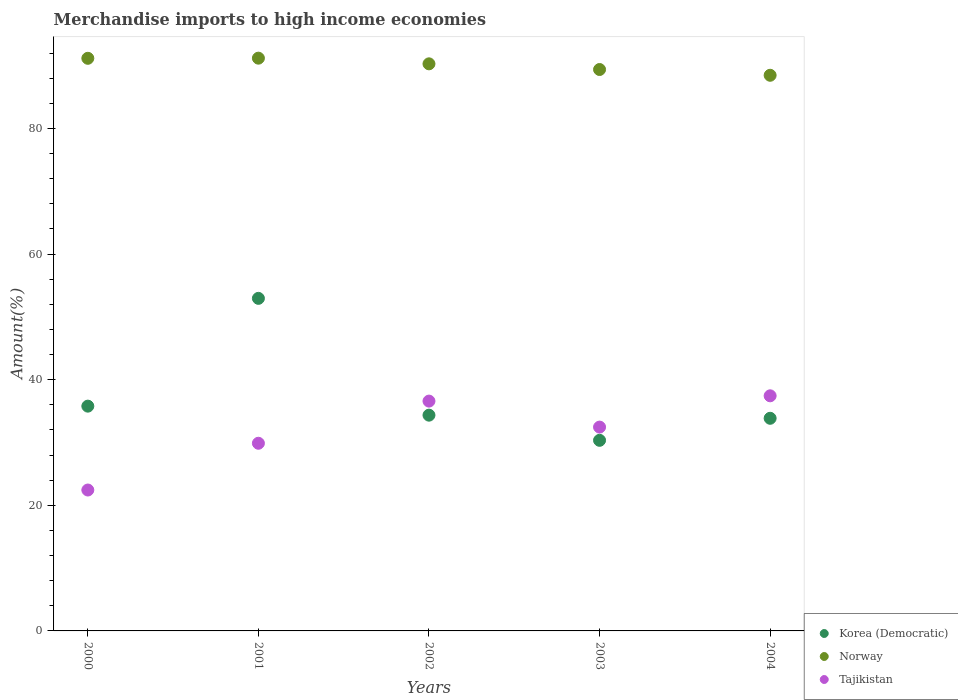How many different coloured dotlines are there?
Your answer should be very brief. 3. What is the percentage of amount earned from merchandise imports in Tajikistan in 2000?
Keep it short and to the point. 22.43. Across all years, what is the maximum percentage of amount earned from merchandise imports in Norway?
Offer a very short reply. 91.18. Across all years, what is the minimum percentage of amount earned from merchandise imports in Norway?
Make the answer very short. 88.46. In which year was the percentage of amount earned from merchandise imports in Norway maximum?
Provide a succinct answer. 2001. In which year was the percentage of amount earned from merchandise imports in Korea (Democratic) minimum?
Offer a very short reply. 2003. What is the total percentage of amount earned from merchandise imports in Tajikistan in the graph?
Keep it short and to the point. 158.77. What is the difference between the percentage of amount earned from merchandise imports in Korea (Democratic) in 2000 and that in 2004?
Your answer should be very brief. 1.93. What is the difference between the percentage of amount earned from merchandise imports in Tajikistan in 2003 and the percentage of amount earned from merchandise imports in Korea (Democratic) in 2001?
Offer a terse response. -20.49. What is the average percentage of amount earned from merchandise imports in Norway per year?
Keep it short and to the point. 90.09. In the year 2001, what is the difference between the percentage of amount earned from merchandise imports in Korea (Democratic) and percentage of amount earned from merchandise imports in Norway?
Provide a short and direct response. -38.24. In how many years, is the percentage of amount earned from merchandise imports in Tajikistan greater than 72 %?
Offer a very short reply. 0. What is the ratio of the percentage of amount earned from merchandise imports in Korea (Democratic) in 2000 to that in 2001?
Provide a succinct answer. 0.68. Is the percentage of amount earned from merchandise imports in Norway in 2002 less than that in 2004?
Give a very brief answer. No. What is the difference between the highest and the second highest percentage of amount earned from merchandise imports in Norway?
Your response must be concise. 0.02. What is the difference between the highest and the lowest percentage of amount earned from merchandise imports in Norway?
Your response must be concise. 2.72. In how many years, is the percentage of amount earned from merchandise imports in Tajikistan greater than the average percentage of amount earned from merchandise imports in Tajikistan taken over all years?
Your answer should be compact. 3. Does the percentage of amount earned from merchandise imports in Norway monotonically increase over the years?
Provide a succinct answer. No. Is the percentage of amount earned from merchandise imports in Norway strictly greater than the percentage of amount earned from merchandise imports in Korea (Democratic) over the years?
Your answer should be compact. Yes. Does the graph contain any zero values?
Keep it short and to the point. No. Where does the legend appear in the graph?
Your response must be concise. Bottom right. How are the legend labels stacked?
Make the answer very short. Vertical. What is the title of the graph?
Provide a short and direct response. Merchandise imports to high income economies. What is the label or title of the Y-axis?
Offer a very short reply. Amount(%). What is the Amount(%) in Korea (Democratic) in 2000?
Give a very brief answer. 35.78. What is the Amount(%) in Norway in 2000?
Offer a terse response. 91.16. What is the Amount(%) in Tajikistan in 2000?
Keep it short and to the point. 22.43. What is the Amount(%) in Korea (Democratic) in 2001?
Offer a very short reply. 52.94. What is the Amount(%) in Norway in 2001?
Offer a terse response. 91.18. What is the Amount(%) in Tajikistan in 2001?
Give a very brief answer. 29.88. What is the Amount(%) in Korea (Democratic) in 2002?
Offer a very short reply. 34.35. What is the Amount(%) in Norway in 2002?
Offer a very short reply. 90.28. What is the Amount(%) in Tajikistan in 2002?
Your response must be concise. 36.59. What is the Amount(%) in Korea (Democratic) in 2003?
Give a very brief answer. 30.34. What is the Amount(%) in Norway in 2003?
Ensure brevity in your answer.  89.37. What is the Amount(%) of Tajikistan in 2003?
Give a very brief answer. 32.45. What is the Amount(%) in Korea (Democratic) in 2004?
Give a very brief answer. 33.85. What is the Amount(%) of Norway in 2004?
Your answer should be compact. 88.46. What is the Amount(%) of Tajikistan in 2004?
Your answer should be very brief. 37.43. Across all years, what is the maximum Amount(%) in Korea (Democratic)?
Provide a short and direct response. 52.94. Across all years, what is the maximum Amount(%) of Norway?
Give a very brief answer. 91.18. Across all years, what is the maximum Amount(%) of Tajikistan?
Give a very brief answer. 37.43. Across all years, what is the minimum Amount(%) in Korea (Democratic)?
Give a very brief answer. 30.34. Across all years, what is the minimum Amount(%) in Norway?
Make the answer very short. 88.46. Across all years, what is the minimum Amount(%) in Tajikistan?
Your answer should be compact. 22.43. What is the total Amount(%) in Korea (Democratic) in the graph?
Ensure brevity in your answer.  187.27. What is the total Amount(%) in Norway in the graph?
Your response must be concise. 450.45. What is the total Amount(%) in Tajikistan in the graph?
Provide a succinct answer. 158.77. What is the difference between the Amount(%) in Korea (Democratic) in 2000 and that in 2001?
Give a very brief answer. -17.16. What is the difference between the Amount(%) of Norway in 2000 and that in 2001?
Provide a short and direct response. -0.02. What is the difference between the Amount(%) in Tajikistan in 2000 and that in 2001?
Offer a very short reply. -7.44. What is the difference between the Amount(%) in Korea (Democratic) in 2000 and that in 2002?
Give a very brief answer. 1.44. What is the difference between the Amount(%) in Norway in 2000 and that in 2002?
Ensure brevity in your answer.  0.88. What is the difference between the Amount(%) in Tajikistan in 2000 and that in 2002?
Your answer should be compact. -14.15. What is the difference between the Amount(%) in Korea (Democratic) in 2000 and that in 2003?
Ensure brevity in your answer.  5.44. What is the difference between the Amount(%) in Norway in 2000 and that in 2003?
Give a very brief answer. 1.78. What is the difference between the Amount(%) in Tajikistan in 2000 and that in 2003?
Ensure brevity in your answer.  -10.02. What is the difference between the Amount(%) in Korea (Democratic) in 2000 and that in 2004?
Offer a very short reply. 1.93. What is the difference between the Amount(%) in Norway in 2000 and that in 2004?
Offer a terse response. 2.7. What is the difference between the Amount(%) in Tajikistan in 2000 and that in 2004?
Offer a terse response. -15. What is the difference between the Amount(%) of Korea (Democratic) in 2001 and that in 2002?
Make the answer very short. 18.59. What is the difference between the Amount(%) of Norway in 2001 and that in 2002?
Make the answer very short. 0.9. What is the difference between the Amount(%) in Tajikistan in 2001 and that in 2002?
Provide a succinct answer. -6.71. What is the difference between the Amount(%) in Korea (Democratic) in 2001 and that in 2003?
Your response must be concise. 22.6. What is the difference between the Amount(%) in Norway in 2001 and that in 2003?
Your answer should be very brief. 1.81. What is the difference between the Amount(%) in Tajikistan in 2001 and that in 2003?
Provide a short and direct response. -2.57. What is the difference between the Amount(%) of Korea (Democratic) in 2001 and that in 2004?
Provide a succinct answer. 19.09. What is the difference between the Amount(%) of Norway in 2001 and that in 2004?
Provide a short and direct response. 2.72. What is the difference between the Amount(%) in Tajikistan in 2001 and that in 2004?
Your answer should be very brief. -7.55. What is the difference between the Amount(%) in Korea (Democratic) in 2002 and that in 2003?
Give a very brief answer. 4.01. What is the difference between the Amount(%) of Norway in 2002 and that in 2003?
Offer a terse response. 0.9. What is the difference between the Amount(%) in Tajikistan in 2002 and that in 2003?
Your answer should be compact. 4.14. What is the difference between the Amount(%) in Korea (Democratic) in 2002 and that in 2004?
Give a very brief answer. 0.5. What is the difference between the Amount(%) in Norway in 2002 and that in 2004?
Offer a very short reply. 1.82. What is the difference between the Amount(%) in Tajikistan in 2002 and that in 2004?
Provide a succinct answer. -0.84. What is the difference between the Amount(%) in Korea (Democratic) in 2003 and that in 2004?
Keep it short and to the point. -3.51. What is the difference between the Amount(%) in Norway in 2003 and that in 2004?
Your answer should be very brief. 0.92. What is the difference between the Amount(%) in Tajikistan in 2003 and that in 2004?
Ensure brevity in your answer.  -4.98. What is the difference between the Amount(%) of Korea (Democratic) in 2000 and the Amount(%) of Norway in 2001?
Provide a succinct answer. -55.4. What is the difference between the Amount(%) in Korea (Democratic) in 2000 and the Amount(%) in Tajikistan in 2001?
Provide a succinct answer. 5.91. What is the difference between the Amount(%) in Norway in 2000 and the Amount(%) in Tajikistan in 2001?
Your response must be concise. 61.28. What is the difference between the Amount(%) in Korea (Democratic) in 2000 and the Amount(%) in Norway in 2002?
Provide a short and direct response. -54.49. What is the difference between the Amount(%) in Korea (Democratic) in 2000 and the Amount(%) in Tajikistan in 2002?
Make the answer very short. -0.8. What is the difference between the Amount(%) in Norway in 2000 and the Amount(%) in Tajikistan in 2002?
Your answer should be compact. 54.57. What is the difference between the Amount(%) in Korea (Democratic) in 2000 and the Amount(%) in Norway in 2003?
Ensure brevity in your answer.  -53.59. What is the difference between the Amount(%) in Korea (Democratic) in 2000 and the Amount(%) in Tajikistan in 2003?
Provide a short and direct response. 3.34. What is the difference between the Amount(%) of Norway in 2000 and the Amount(%) of Tajikistan in 2003?
Offer a terse response. 58.71. What is the difference between the Amount(%) of Korea (Democratic) in 2000 and the Amount(%) of Norway in 2004?
Offer a terse response. -52.67. What is the difference between the Amount(%) in Korea (Democratic) in 2000 and the Amount(%) in Tajikistan in 2004?
Make the answer very short. -1.64. What is the difference between the Amount(%) of Norway in 2000 and the Amount(%) of Tajikistan in 2004?
Offer a very short reply. 53.73. What is the difference between the Amount(%) in Korea (Democratic) in 2001 and the Amount(%) in Norway in 2002?
Keep it short and to the point. -37.34. What is the difference between the Amount(%) of Korea (Democratic) in 2001 and the Amount(%) of Tajikistan in 2002?
Provide a short and direct response. 16.36. What is the difference between the Amount(%) in Norway in 2001 and the Amount(%) in Tajikistan in 2002?
Provide a succinct answer. 54.59. What is the difference between the Amount(%) of Korea (Democratic) in 2001 and the Amount(%) of Norway in 2003?
Give a very brief answer. -36.43. What is the difference between the Amount(%) of Korea (Democratic) in 2001 and the Amount(%) of Tajikistan in 2003?
Your answer should be very brief. 20.49. What is the difference between the Amount(%) of Norway in 2001 and the Amount(%) of Tajikistan in 2003?
Offer a very short reply. 58.73. What is the difference between the Amount(%) of Korea (Democratic) in 2001 and the Amount(%) of Norway in 2004?
Make the answer very short. -35.51. What is the difference between the Amount(%) in Korea (Democratic) in 2001 and the Amount(%) in Tajikistan in 2004?
Provide a succinct answer. 15.51. What is the difference between the Amount(%) of Norway in 2001 and the Amount(%) of Tajikistan in 2004?
Make the answer very short. 53.75. What is the difference between the Amount(%) in Korea (Democratic) in 2002 and the Amount(%) in Norway in 2003?
Give a very brief answer. -55.03. What is the difference between the Amount(%) in Korea (Democratic) in 2002 and the Amount(%) in Tajikistan in 2003?
Provide a short and direct response. 1.9. What is the difference between the Amount(%) of Norway in 2002 and the Amount(%) of Tajikistan in 2003?
Provide a succinct answer. 57.83. What is the difference between the Amount(%) in Korea (Democratic) in 2002 and the Amount(%) in Norway in 2004?
Your response must be concise. -54.11. What is the difference between the Amount(%) in Korea (Democratic) in 2002 and the Amount(%) in Tajikistan in 2004?
Your response must be concise. -3.08. What is the difference between the Amount(%) of Norway in 2002 and the Amount(%) of Tajikistan in 2004?
Your response must be concise. 52.85. What is the difference between the Amount(%) of Korea (Democratic) in 2003 and the Amount(%) of Norway in 2004?
Your answer should be very brief. -58.11. What is the difference between the Amount(%) of Korea (Democratic) in 2003 and the Amount(%) of Tajikistan in 2004?
Provide a succinct answer. -7.09. What is the difference between the Amount(%) in Norway in 2003 and the Amount(%) in Tajikistan in 2004?
Give a very brief answer. 51.95. What is the average Amount(%) in Korea (Democratic) per year?
Provide a short and direct response. 37.45. What is the average Amount(%) in Norway per year?
Provide a succinct answer. 90.09. What is the average Amount(%) in Tajikistan per year?
Your answer should be compact. 31.75. In the year 2000, what is the difference between the Amount(%) of Korea (Democratic) and Amount(%) of Norway?
Offer a terse response. -55.37. In the year 2000, what is the difference between the Amount(%) of Korea (Democratic) and Amount(%) of Tajikistan?
Ensure brevity in your answer.  13.35. In the year 2000, what is the difference between the Amount(%) in Norway and Amount(%) in Tajikistan?
Provide a short and direct response. 68.73. In the year 2001, what is the difference between the Amount(%) in Korea (Democratic) and Amount(%) in Norway?
Your response must be concise. -38.24. In the year 2001, what is the difference between the Amount(%) of Korea (Democratic) and Amount(%) of Tajikistan?
Keep it short and to the point. 23.07. In the year 2001, what is the difference between the Amount(%) in Norway and Amount(%) in Tajikistan?
Your answer should be compact. 61.3. In the year 2002, what is the difference between the Amount(%) in Korea (Democratic) and Amount(%) in Norway?
Ensure brevity in your answer.  -55.93. In the year 2002, what is the difference between the Amount(%) of Korea (Democratic) and Amount(%) of Tajikistan?
Your answer should be very brief. -2.24. In the year 2002, what is the difference between the Amount(%) in Norway and Amount(%) in Tajikistan?
Your answer should be compact. 53.69. In the year 2003, what is the difference between the Amount(%) in Korea (Democratic) and Amount(%) in Norway?
Give a very brief answer. -59.03. In the year 2003, what is the difference between the Amount(%) of Korea (Democratic) and Amount(%) of Tajikistan?
Provide a short and direct response. -2.11. In the year 2003, what is the difference between the Amount(%) in Norway and Amount(%) in Tajikistan?
Provide a short and direct response. 56.93. In the year 2004, what is the difference between the Amount(%) in Korea (Democratic) and Amount(%) in Norway?
Provide a succinct answer. -54.61. In the year 2004, what is the difference between the Amount(%) of Korea (Democratic) and Amount(%) of Tajikistan?
Your answer should be very brief. -3.58. In the year 2004, what is the difference between the Amount(%) of Norway and Amount(%) of Tajikistan?
Keep it short and to the point. 51.03. What is the ratio of the Amount(%) of Korea (Democratic) in 2000 to that in 2001?
Ensure brevity in your answer.  0.68. What is the ratio of the Amount(%) of Norway in 2000 to that in 2001?
Offer a very short reply. 1. What is the ratio of the Amount(%) of Tajikistan in 2000 to that in 2001?
Provide a succinct answer. 0.75. What is the ratio of the Amount(%) of Korea (Democratic) in 2000 to that in 2002?
Your answer should be compact. 1.04. What is the ratio of the Amount(%) of Norway in 2000 to that in 2002?
Provide a succinct answer. 1.01. What is the ratio of the Amount(%) in Tajikistan in 2000 to that in 2002?
Offer a very short reply. 0.61. What is the ratio of the Amount(%) in Korea (Democratic) in 2000 to that in 2003?
Ensure brevity in your answer.  1.18. What is the ratio of the Amount(%) in Tajikistan in 2000 to that in 2003?
Your answer should be compact. 0.69. What is the ratio of the Amount(%) in Korea (Democratic) in 2000 to that in 2004?
Your answer should be very brief. 1.06. What is the ratio of the Amount(%) of Norway in 2000 to that in 2004?
Make the answer very short. 1.03. What is the ratio of the Amount(%) in Tajikistan in 2000 to that in 2004?
Ensure brevity in your answer.  0.6. What is the ratio of the Amount(%) in Korea (Democratic) in 2001 to that in 2002?
Your answer should be compact. 1.54. What is the ratio of the Amount(%) of Tajikistan in 2001 to that in 2002?
Give a very brief answer. 0.82. What is the ratio of the Amount(%) of Korea (Democratic) in 2001 to that in 2003?
Your answer should be compact. 1.74. What is the ratio of the Amount(%) of Norway in 2001 to that in 2003?
Keep it short and to the point. 1.02. What is the ratio of the Amount(%) in Tajikistan in 2001 to that in 2003?
Give a very brief answer. 0.92. What is the ratio of the Amount(%) of Korea (Democratic) in 2001 to that in 2004?
Your answer should be compact. 1.56. What is the ratio of the Amount(%) of Norway in 2001 to that in 2004?
Give a very brief answer. 1.03. What is the ratio of the Amount(%) of Tajikistan in 2001 to that in 2004?
Provide a short and direct response. 0.8. What is the ratio of the Amount(%) of Korea (Democratic) in 2002 to that in 2003?
Keep it short and to the point. 1.13. What is the ratio of the Amount(%) of Norway in 2002 to that in 2003?
Your response must be concise. 1.01. What is the ratio of the Amount(%) in Tajikistan in 2002 to that in 2003?
Give a very brief answer. 1.13. What is the ratio of the Amount(%) in Korea (Democratic) in 2002 to that in 2004?
Your answer should be very brief. 1.01. What is the ratio of the Amount(%) of Norway in 2002 to that in 2004?
Provide a succinct answer. 1.02. What is the ratio of the Amount(%) of Tajikistan in 2002 to that in 2004?
Offer a very short reply. 0.98. What is the ratio of the Amount(%) of Korea (Democratic) in 2003 to that in 2004?
Your answer should be compact. 0.9. What is the ratio of the Amount(%) in Norway in 2003 to that in 2004?
Your answer should be very brief. 1.01. What is the ratio of the Amount(%) of Tajikistan in 2003 to that in 2004?
Make the answer very short. 0.87. What is the difference between the highest and the second highest Amount(%) in Korea (Democratic)?
Your answer should be very brief. 17.16. What is the difference between the highest and the second highest Amount(%) in Norway?
Make the answer very short. 0.02. What is the difference between the highest and the second highest Amount(%) in Tajikistan?
Your answer should be very brief. 0.84. What is the difference between the highest and the lowest Amount(%) of Korea (Democratic)?
Provide a short and direct response. 22.6. What is the difference between the highest and the lowest Amount(%) of Norway?
Provide a succinct answer. 2.72. What is the difference between the highest and the lowest Amount(%) of Tajikistan?
Offer a terse response. 15. 